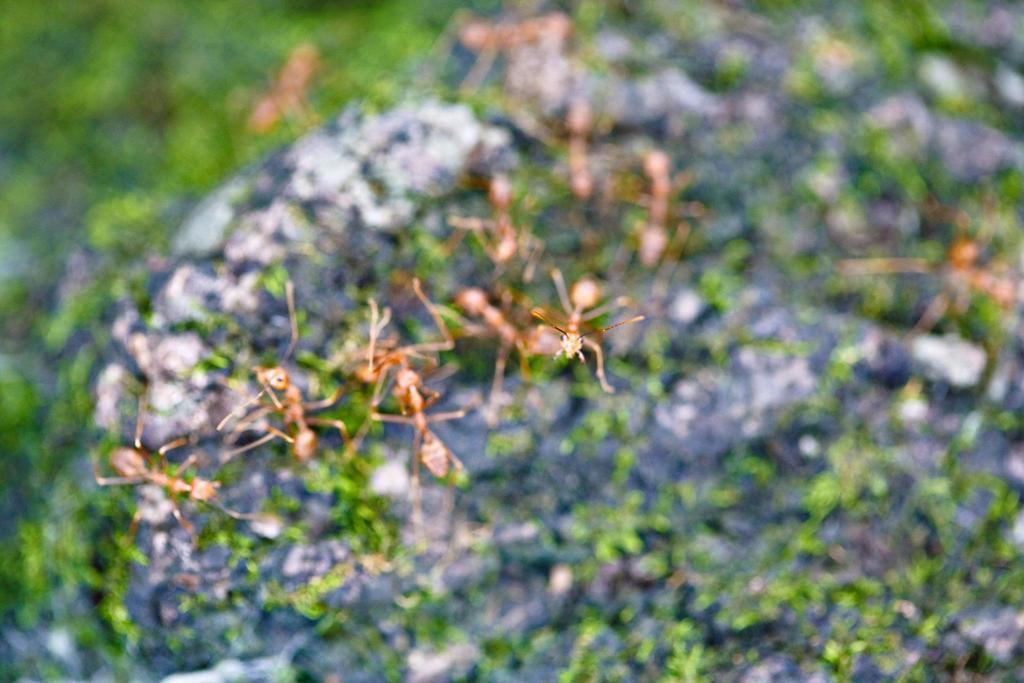What type of creatures can be seen in the image? There are ants in the image. Can you describe the background of the image? The background of the image is blurry. What type of cooking utensil can be seen in the image? There is no cooking utensil present in the image. What type of gardening tool can be seen in the image? There is no gardening tool present in the image. 